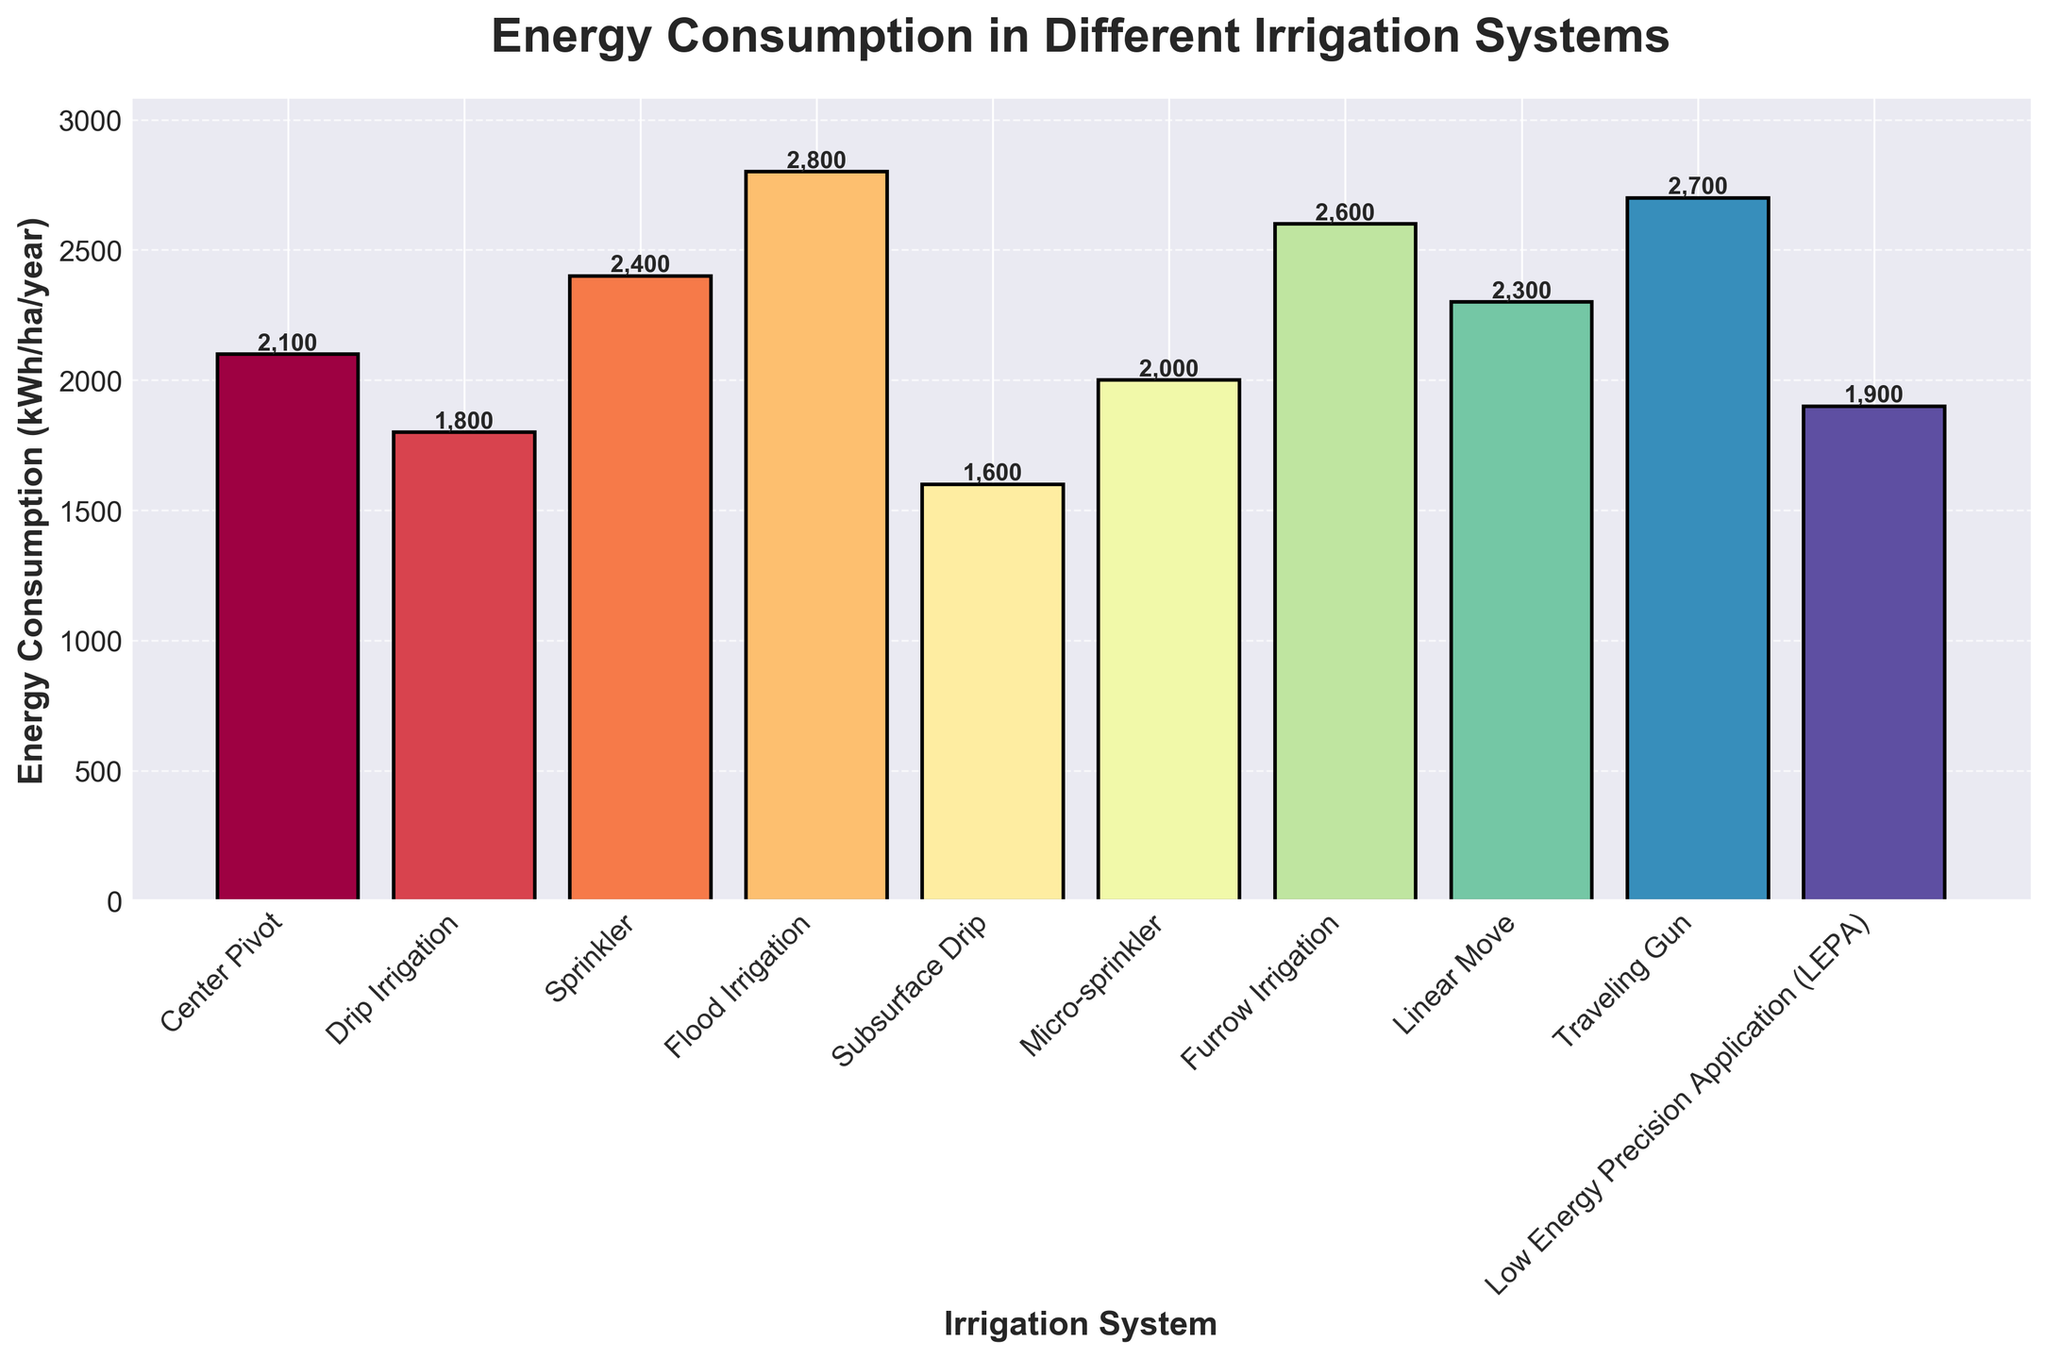What's the energy consumption of the irrigation system with the highest usage? The bar chart shows energy consumption for various irrigation systems. The highest bar indicates Flood Irrigation at 2800 kWh/ha/year.
Answer: 2800 kWh/ha/year Which irrigation system has the least energy consumption? The bar for Subsurface Drip is the shortest, indicating it has the least energy consumption at 1600 kWh/ha/year.
Answer: Subsurface Drip How much more energy does Furrow Irrigation consume compared to Drip Irrigation? The bar for Furrow Irrigation is at 2600 kWh/ha/year while the bar for Drip Irrigation is at 1800 kWh/ha/year. The difference is 2600 - 1800 = 800 kWh/ha/year.
Answer: 800 kWh/ha/year Which irrigation systems consume less than 2000 kWh/ha/year of energy? Subsurface Drip (1600 kWh/ha/year), Drip Irrigation (1800 kWh/ha/year) and LEPA (1900 kWh/ha/year) are the bars shorter than 2000 kWh/ha/year.
Answer: Subsurface Drip, Drip Irrigation, LEPA What is the average energy consumption across all irrigation systems? Sum all energy consumption values: 2100 + 1800 + 2400 + 2800 + 1600 + 2000 + 2600 + 2300 + 2700 + 1900 = 22200 kWh/ha/year. Divide by the number of systems, 10: 22200 / 10 = 2220 kWh/ha/year.
Answer: 2220 kWh/ha/year Which irrigation system is represented with the third highest energy consumption? From the highest energy consumption down, Flood Irrigation is first (2800 kWh/ha/year), Traveling Gun is second (2700 kWh/ha/year), and Furrow Irrigation is third (2600 kWh/ha/year).
Answer: Furrow Irrigation By how much does the energy consumption for Sprinkler exceed Micro-sprinkler? The bar for Sprinkler is at 2400 kWh/ha/year; the bar for Micro-sprinkler is at 2000 kWh/ha/year. The difference is 2400 - 2000 = 400 kWh/ha/year.
Answer: 400 kWh/ha/year What is the median energy consumption value among all irrigation systems? Sort the values: 1600, 1800, 1900, 2000, 2100, 2300, 2400, 2600, 2700, 2800. Median is the average of the 5th and 6th values: (2100 + 2300) / 2 = 2200 kWh/ha/year.
Answer: 2200 kWh/ha/year Which irrigation system’s energy consumption is closest to the median value? The median value is 2200 kWh/ha/year. Closest bars are Center Pivot (2100 kWh/ha/year) and Linear Move (2300 kWh/ha/year). Linear Move (2300 kWh/ha/year) is closer with a difference of 100 compared to Center Pivot’s difference of 100, so both are equally close.
Answer: Center Pivot, Linear Move How much total energy would be consumed by using both Traveling Gun and Low Energy Precision Application systems combined? Adding the two values gives 2700 kWh/ha/year (Traveling Gun) + 1900 kWh/ha/year (LEPA) = 4600 kWh/ha/year.
Answer: 4600 kWh/ha/year 